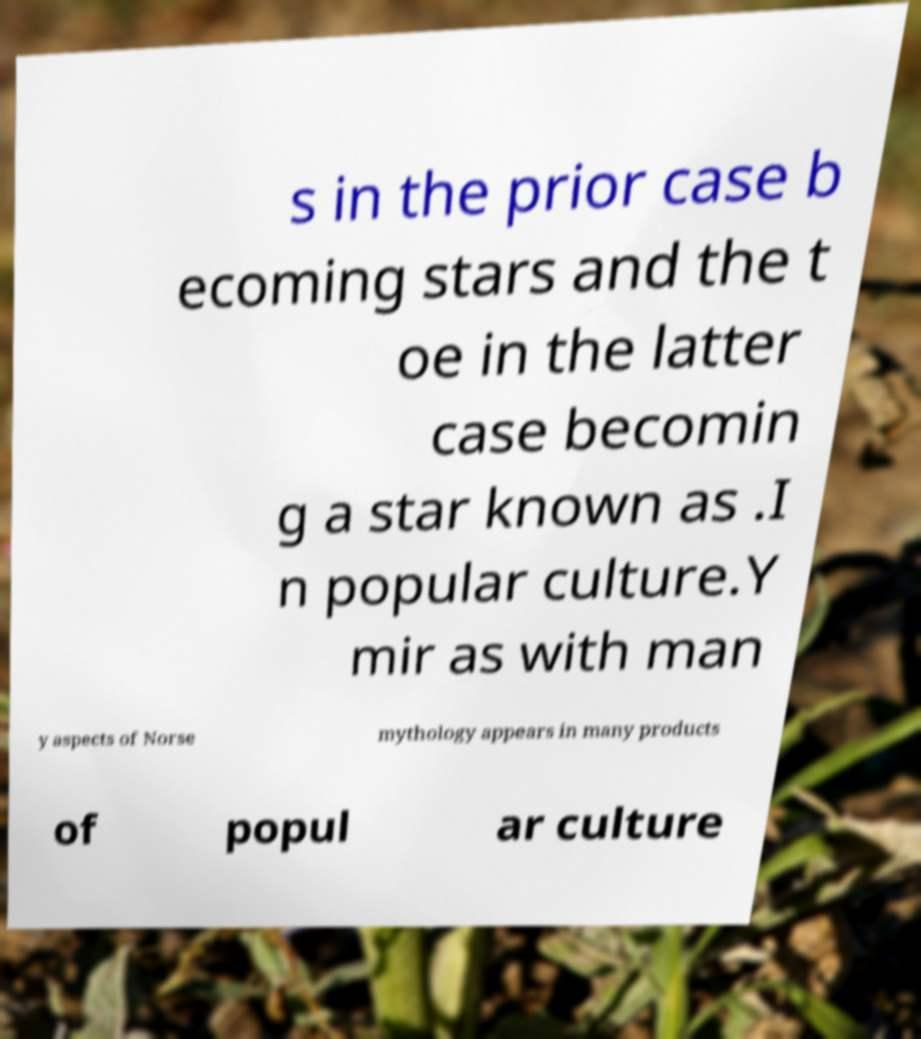There's text embedded in this image that I need extracted. Can you transcribe it verbatim? s in the prior case b ecoming stars and the t oe in the latter case becomin g a star known as .I n popular culture.Y mir as with man y aspects of Norse mythology appears in many products of popul ar culture 